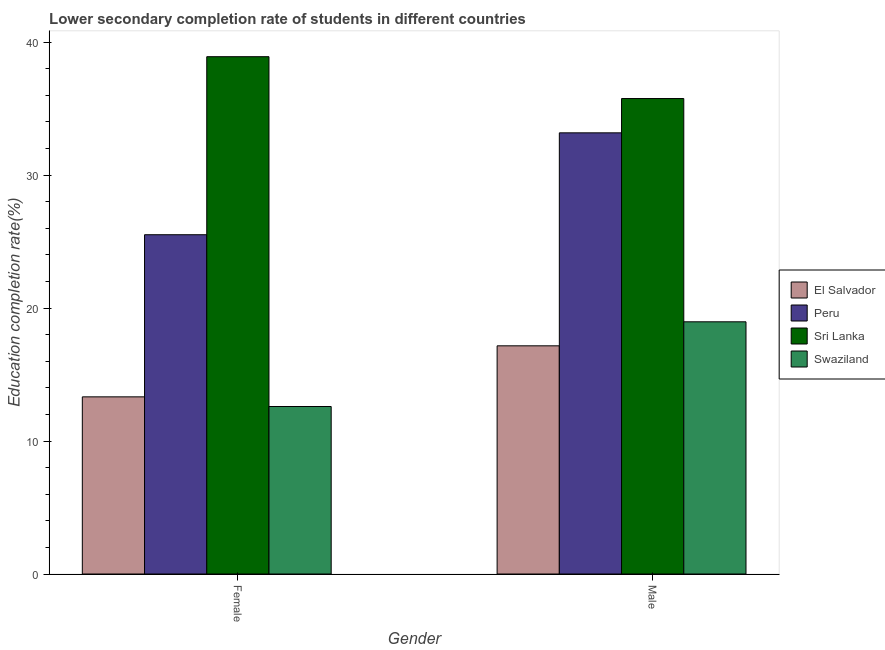How many bars are there on the 2nd tick from the left?
Offer a very short reply. 4. What is the education completion rate of female students in Sri Lanka?
Your response must be concise. 38.91. Across all countries, what is the maximum education completion rate of male students?
Make the answer very short. 35.76. Across all countries, what is the minimum education completion rate of male students?
Your response must be concise. 17.16. In which country was the education completion rate of female students maximum?
Keep it short and to the point. Sri Lanka. In which country was the education completion rate of male students minimum?
Ensure brevity in your answer.  El Salvador. What is the total education completion rate of male students in the graph?
Give a very brief answer. 105.07. What is the difference between the education completion rate of male students in El Salvador and that in Swaziland?
Offer a very short reply. -1.81. What is the difference between the education completion rate of male students in Peru and the education completion rate of female students in Sri Lanka?
Make the answer very short. -5.73. What is the average education completion rate of male students per country?
Your answer should be very brief. 26.27. What is the difference between the education completion rate of female students and education completion rate of male students in Swaziland?
Offer a very short reply. -6.37. In how many countries, is the education completion rate of male students greater than 34 %?
Your response must be concise. 1. What is the ratio of the education completion rate of male students in Sri Lanka to that in Swaziland?
Offer a very short reply. 1.89. In how many countries, is the education completion rate of male students greater than the average education completion rate of male students taken over all countries?
Your answer should be very brief. 2. What does the 3rd bar from the left in Female represents?
Offer a terse response. Sri Lanka. What does the 1st bar from the right in Male represents?
Provide a short and direct response. Swaziland. How many bars are there?
Provide a short and direct response. 8. How many countries are there in the graph?
Ensure brevity in your answer.  4. What is the difference between two consecutive major ticks on the Y-axis?
Offer a very short reply. 10. Are the values on the major ticks of Y-axis written in scientific E-notation?
Your answer should be very brief. No. Where does the legend appear in the graph?
Your response must be concise. Center right. How many legend labels are there?
Offer a very short reply. 4. How are the legend labels stacked?
Your response must be concise. Vertical. What is the title of the graph?
Ensure brevity in your answer.  Lower secondary completion rate of students in different countries. What is the label or title of the X-axis?
Give a very brief answer. Gender. What is the label or title of the Y-axis?
Keep it short and to the point. Education completion rate(%). What is the Education completion rate(%) in El Salvador in Female?
Offer a terse response. 13.32. What is the Education completion rate(%) of Peru in Female?
Your response must be concise. 25.52. What is the Education completion rate(%) in Sri Lanka in Female?
Your answer should be compact. 38.91. What is the Education completion rate(%) in Swaziland in Female?
Ensure brevity in your answer.  12.6. What is the Education completion rate(%) of El Salvador in Male?
Your answer should be very brief. 17.16. What is the Education completion rate(%) in Peru in Male?
Make the answer very short. 33.18. What is the Education completion rate(%) in Sri Lanka in Male?
Keep it short and to the point. 35.76. What is the Education completion rate(%) in Swaziland in Male?
Provide a succinct answer. 18.97. Across all Gender, what is the maximum Education completion rate(%) in El Salvador?
Your answer should be very brief. 17.16. Across all Gender, what is the maximum Education completion rate(%) of Peru?
Provide a succinct answer. 33.18. Across all Gender, what is the maximum Education completion rate(%) of Sri Lanka?
Ensure brevity in your answer.  38.91. Across all Gender, what is the maximum Education completion rate(%) in Swaziland?
Your answer should be very brief. 18.97. Across all Gender, what is the minimum Education completion rate(%) of El Salvador?
Your answer should be very brief. 13.32. Across all Gender, what is the minimum Education completion rate(%) of Peru?
Offer a very short reply. 25.52. Across all Gender, what is the minimum Education completion rate(%) of Sri Lanka?
Make the answer very short. 35.76. Across all Gender, what is the minimum Education completion rate(%) of Swaziland?
Your answer should be compact. 12.6. What is the total Education completion rate(%) of El Salvador in the graph?
Offer a terse response. 30.48. What is the total Education completion rate(%) of Peru in the graph?
Your response must be concise. 58.7. What is the total Education completion rate(%) of Sri Lanka in the graph?
Give a very brief answer. 74.67. What is the total Education completion rate(%) in Swaziland in the graph?
Your answer should be compact. 31.57. What is the difference between the Education completion rate(%) of El Salvador in Female and that in Male?
Offer a terse response. -3.84. What is the difference between the Education completion rate(%) of Peru in Female and that in Male?
Offer a very short reply. -7.66. What is the difference between the Education completion rate(%) of Sri Lanka in Female and that in Male?
Keep it short and to the point. 3.15. What is the difference between the Education completion rate(%) of Swaziland in Female and that in Male?
Your response must be concise. -6.37. What is the difference between the Education completion rate(%) in El Salvador in Female and the Education completion rate(%) in Peru in Male?
Your response must be concise. -19.86. What is the difference between the Education completion rate(%) of El Salvador in Female and the Education completion rate(%) of Sri Lanka in Male?
Ensure brevity in your answer.  -22.44. What is the difference between the Education completion rate(%) in El Salvador in Female and the Education completion rate(%) in Swaziland in Male?
Your answer should be compact. -5.64. What is the difference between the Education completion rate(%) in Peru in Female and the Education completion rate(%) in Sri Lanka in Male?
Provide a succinct answer. -10.24. What is the difference between the Education completion rate(%) of Peru in Female and the Education completion rate(%) of Swaziland in Male?
Ensure brevity in your answer.  6.55. What is the difference between the Education completion rate(%) in Sri Lanka in Female and the Education completion rate(%) in Swaziland in Male?
Offer a very short reply. 19.94. What is the average Education completion rate(%) of El Salvador per Gender?
Provide a short and direct response. 15.24. What is the average Education completion rate(%) in Peru per Gender?
Make the answer very short. 29.35. What is the average Education completion rate(%) of Sri Lanka per Gender?
Make the answer very short. 37.33. What is the average Education completion rate(%) of Swaziland per Gender?
Provide a succinct answer. 15.78. What is the difference between the Education completion rate(%) in El Salvador and Education completion rate(%) in Peru in Female?
Ensure brevity in your answer.  -12.19. What is the difference between the Education completion rate(%) of El Salvador and Education completion rate(%) of Sri Lanka in Female?
Offer a very short reply. -25.58. What is the difference between the Education completion rate(%) of El Salvador and Education completion rate(%) of Swaziland in Female?
Offer a terse response. 0.73. What is the difference between the Education completion rate(%) in Peru and Education completion rate(%) in Sri Lanka in Female?
Your answer should be compact. -13.39. What is the difference between the Education completion rate(%) in Peru and Education completion rate(%) in Swaziland in Female?
Provide a short and direct response. 12.92. What is the difference between the Education completion rate(%) in Sri Lanka and Education completion rate(%) in Swaziland in Female?
Your answer should be compact. 26.31. What is the difference between the Education completion rate(%) of El Salvador and Education completion rate(%) of Peru in Male?
Offer a very short reply. -16.02. What is the difference between the Education completion rate(%) of El Salvador and Education completion rate(%) of Sri Lanka in Male?
Provide a succinct answer. -18.6. What is the difference between the Education completion rate(%) in El Salvador and Education completion rate(%) in Swaziland in Male?
Offer a very short reply. -1.81. What is the difference between the Education completion rate(%) of Peru and Education completion rate(%) of Sri Lanka in Male?
Make the answer very short. -2.58. What is the difference between the Education completion rate(%) in Peru and Education completion rate(%) in Swaziland in Male?
Give a very brief answer. 14.21. What is the difference between the Education completion rate(%) in Sri Lanka and Education completion rate(%) in Swaziland in Male?
Offer a very short reply. 16.79. What is the ratio of the Education completion rate(%) in El Salvador in Female to that in Male?
Provide a succinct answer. 0.78. What is the ratio of the Education completion rate(%) in Peru in Female to that in Male?
Your answer should be compact. 0.77. What is the ratio of the Education completion rate(%) in Sri Lanka in Female to that in Male?
Your answer should be compact. 1.09. What is the ratio of the Education completion rate(%) in Swaziland in Female to that in Male?
Your answer should be compact. 0.66. What is the difference between the highest and the second highest Education completion rate(%) in El Salvador?
Your answer should be very brief. 3.84. What is the difference between the highest and the second highest Education completion rate(%) of Peru?
Ensure brevity in your answer.  7.66. What is the difference between the highest and the second highest Education completion rate(%) in Sri Lanka?
Keep it short and to the point. 3.15. What is the difference between the highest and the second highest Education completion rate(%) in Swaziland?
Your response must be concise. 6.37. What is the difference between the highest and the lowest Education completion rate(%) in El Salvador?
Ensure brevity in your answer.  3.84. What is the difference between the highest and the lowest Education completion rate(%) of Peru?
Provide a succinct answer. 7.66. What is the difference between the highest and the lowest Education completion rate(%) in Sri Lanka?
Keep it short and to the point. 3.15. What is the difference between the highest and the lowest Education completion rate(%) of Swaziland?
Offer a very short reply. 6.37. 